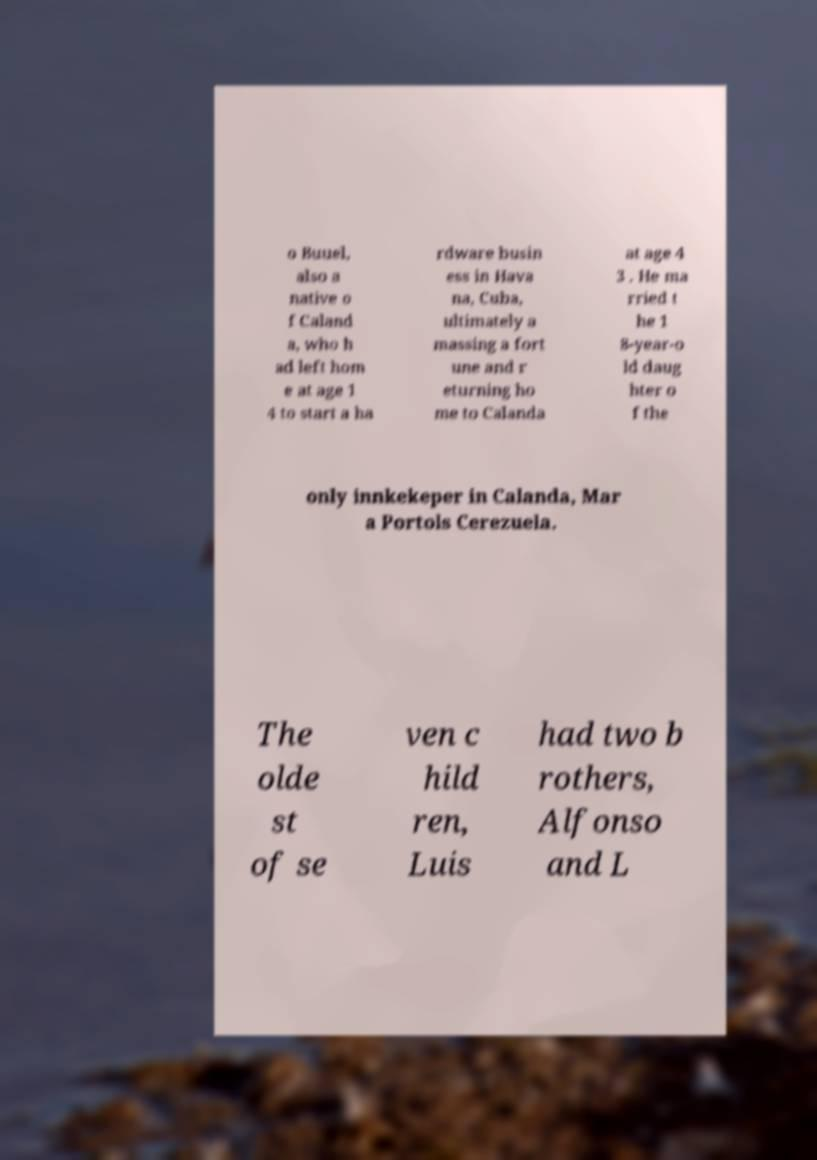Could you assist in decoding the text presented in this image and type it out clearly? o Buuel, also a native o f Caland a, who h ad left hom e at age 1 4 to start a ha rdware busin ess in Hava na, Cuba, ultimately a massing a fort une and r eturning ho me to Calanda at age 4 3 . He ma rried t he 1 8-year-o ld daug hter o f the only innkekeper in Calanda, Mar a Portols Cerezuela. The olde st of se ven c hild ren, Luis had two b rothers, Alfonso and L 